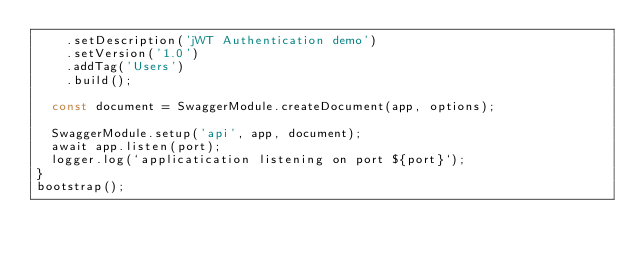Convert code to text. <code><loc_0><loc_0><loc_500><loc_500><_TypeScript_>    .setDescription('jWT Authentication demo')
    .setVersion('1.0')
    .addTag('Users')
    .build();

  const document = SwaggerModule.createDocument(app, options);

  SwaggerModule.setup('api', app, document);
  await app.listen(port);
  logger.log(`applicatication listening on port ${port}`);
}
bootstrap();
</code> 